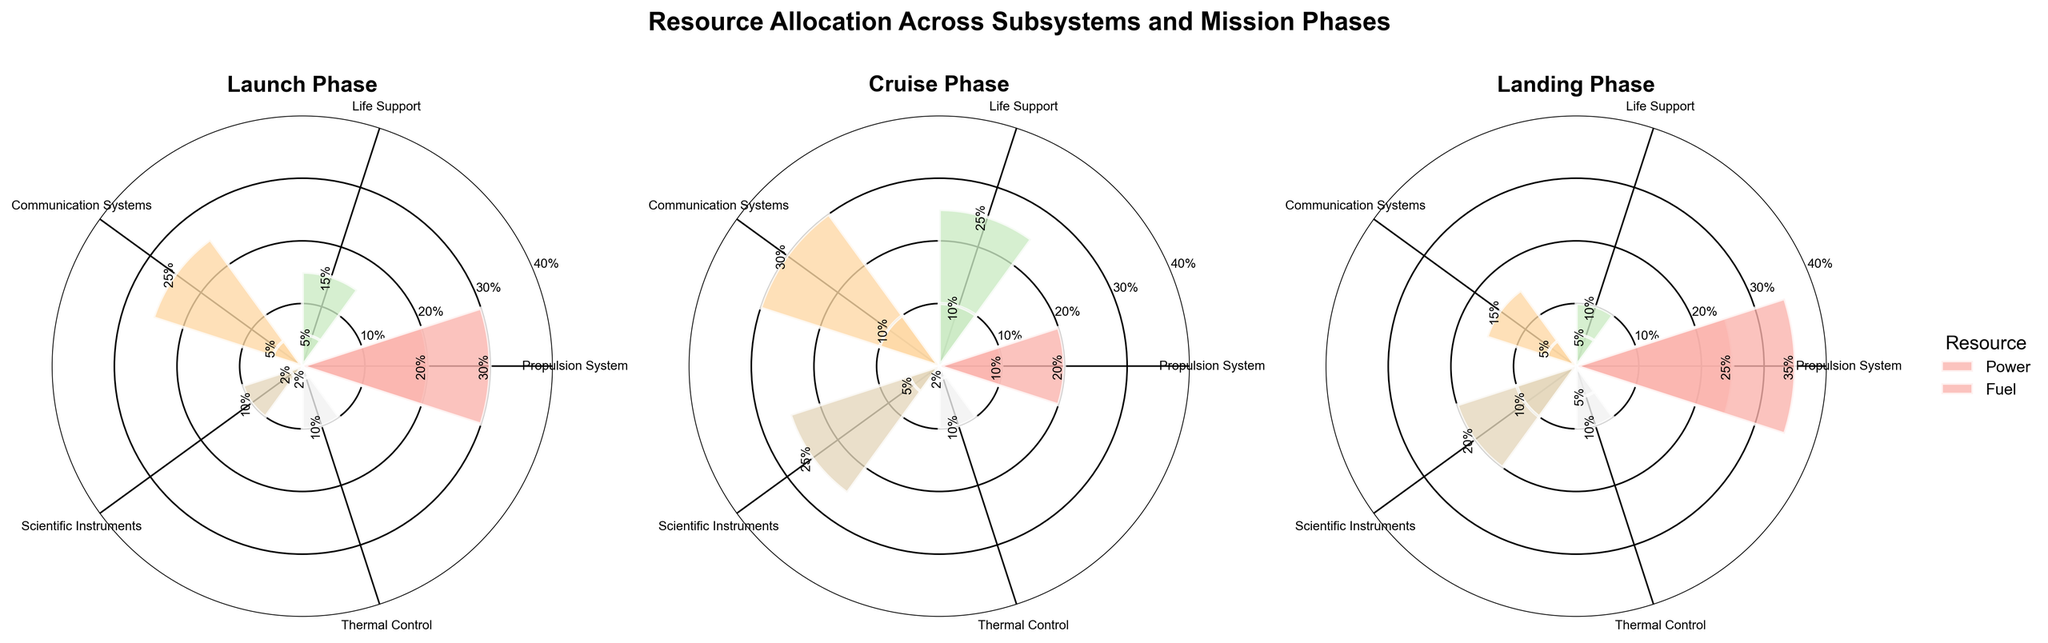What is the title of the figure? The title is located at the top of the figure in larger, bold text. The title helps in understanding the overall theme and focus of the figure.
Answer: Resource Allocation Across Subsystems and Mission Phases Which subsystem takes the highest percentage of power during the Cruise phase? By looking at the `Cruise Phase` plot and comparing the height of the bars for each subsystem, we can identify the one with the highest percentage of power allocation.
Answer: Communication Systems During the Landing phase, how much more power does the Propulsion System use compared to the Thermal Control system? In the `Landing Phase` plot, identify the bars for Propulsion System and Thermal Control System under power. Propulsion System has 25% and Thermal Control has 10%. Subtract the Thermal Control value from the Propulsion System value to find the difference. 25% - 10% = 15%
Answer: 15% What is the total power allocation percentage for the Life Support system across all phases? Sum the percentages of power allocation for the Life Support system in each plot. Launch: 15%, Cruise: 25%, Landing: 10%. Total = 15% + 25% + 10% = 50%
Answer: 50% What subsystem has the lowest fuel allocation in the Launch phase? Identify the bars representing fuel allocation in the `Launch Phase` plot and find the one with the smallest percentage.
Answer: Thermal Control Compare the percentage of power allocation for Scientific Instruments between the Cruise and Landing phases. Examine the `Cruise Phase` and `Landing Phase` plots, locate the bars for Scientific Instruments - power, and compare their heights. Cruise: 25%, Landing: 20%.
Answer: 25% and 20% How does the fuel allocation of Communication Systems in the Cruise phase compare with that in the Launch phase? Locate the `Communication Systems` bars for fuel in the `Launch Phase` and `Cruise Phase` plots and compare their heights. Launch: 5%, Cruise: 10%.
Answer: Cruise is 5% higher than Launch What's the average percentage of fuel allocation across all subsystems in the Landing phase? Add the fuel percentages for all subsystems in the `Landing Phase` plot and divide by the number of subsystems. Propulsion: 35%, Life Support: 5%, Communication Systems: 5%, Scientific Instruments: 10%, Thermal Control: 5%. Total = 35% + 5% + 5% + 10% + 5% = 60%. Average = 60% / 5 = 12%
Answer: 12% Which subsystem consumes the least power in the Launch phase? Look at the `Launch Phase` plot and identify the subsystem with the shortest bar under power.
Answer: Scientific Instruments and Thermal Control During which mission phase does the Life Support system consume the most fuel? Compare the heights of the Life Support fuel bars in each phase (Launch, Cruise, Landing) and identify the highest one. Cruise: 10%
Answer: Cruise 